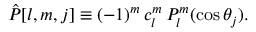Convert formula to latex. <formula><loc_0><loc_0><loc_500><loc_500>\hat { P } [ l , m , j ] \equiv ( - 1 ) ^ { m } \, c _ { l } ^ { m } \, P _ { l } ^ { m } ( \cos \theta _ { j } ) .</formula> 